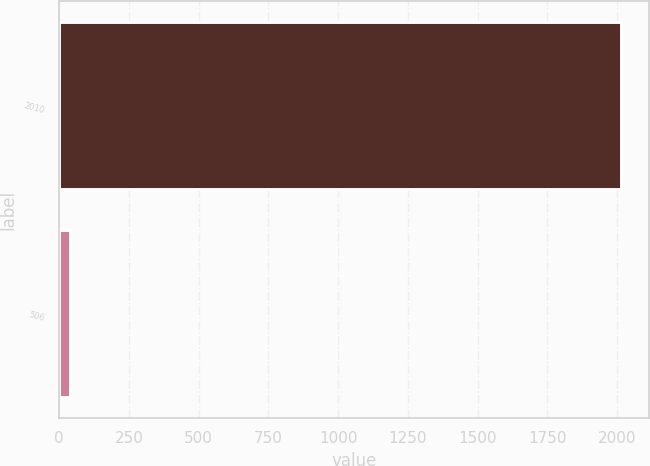<chart> <loc_0><loc_0><loc_500><loc_500><bar_chart><fcel>2010<fcel>506<nl><fcel>2012<fcel>39.8<nl></chart> 